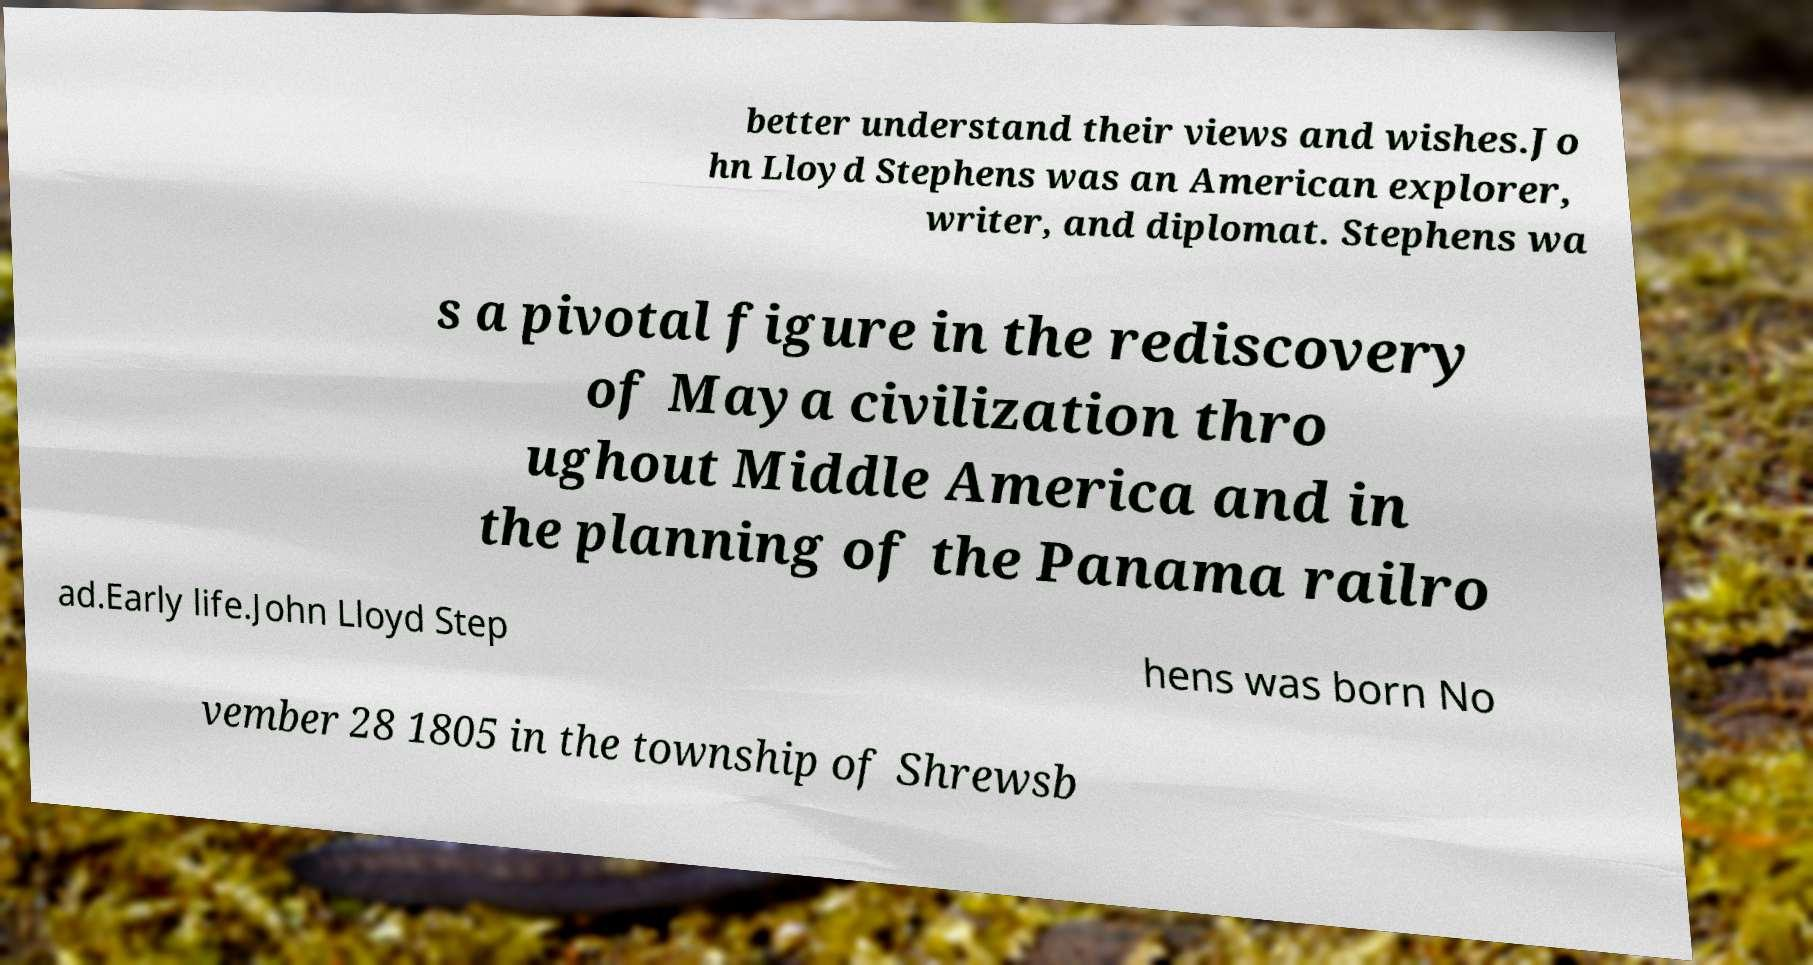Can you accurately transcribe the text from the provided image for me? better understand their views and wishes.Jo hn Lloyd Stephens was an American explorer, writer, and diplomat. Stephens wa s a pivotal figure in the rediscovery of Maya civilization thro ughout Middle America and in the planning of the Panama railro ad.Early life.John Lloyd Step hens was born No vember 28 1805 in the township of Shrewsb 